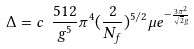Convert formula to latex. <formula><loc_0><loc_0><loc_500><loc_500>\Delta = c \ \frac { 5 1 2 } { g ^ { 5 } } \pi ^ { 4 } ( \frac { 2 } { N _ { f } } ) ^ { 5 / 2 } \mu e ^ { - \frac { 3 \pi ^ { 2 } } { \sqrt { 2 } g } }</formula> 